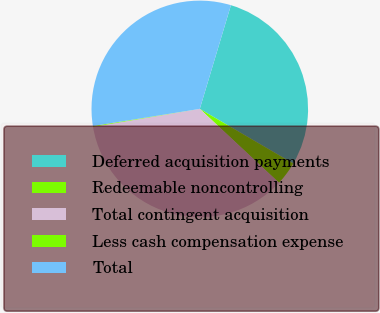<chart> <loc_0><loc_0><loc_500><loc_500><pie_chart><fcel>Deferred acquisition payments<fcel>Redeemable noncontrolling<fcel>Total contingent acquisition<fcel>Less cash compensation expense<fcel>Total<nl><fcel>28.77%<fcel>3.53%<fcel>35.4%<fcel>0.12%<fcel>32.18%<nl></chart> 